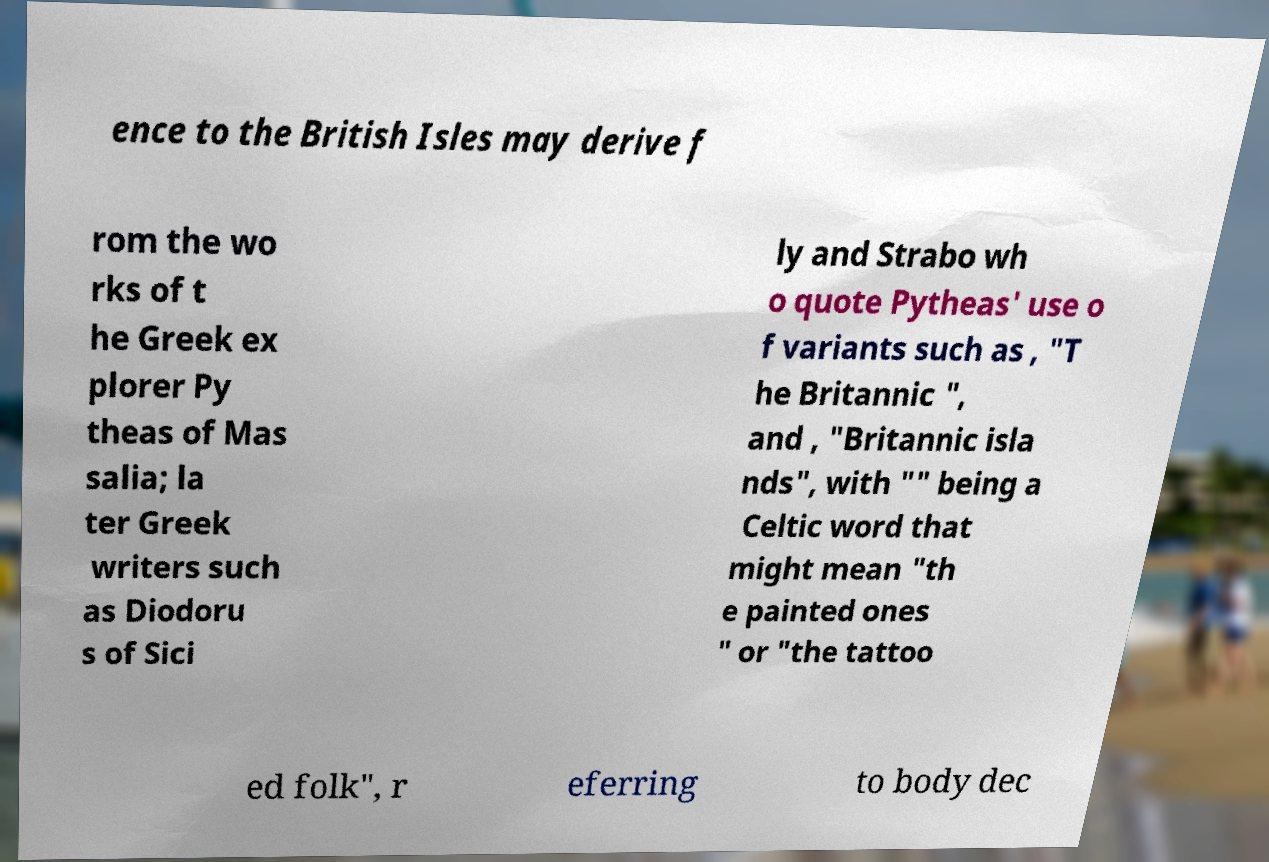Can you accurately transcribe the text from the provided image for me? ence to the British Isles may derive f rom the wo rks of t he Greek ex plorer Py theas of Mas salia; la ter Greek writers such as Diodoru s of Sici ly and Strabo wh o quote Pytheas' use o f variants such as , "T he Britannic ", and , "Britannic isla nds", with "" being a Celtic word that might mean "th e painted ones " or "the tattoo ed folk", r eferring to body dec 